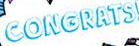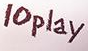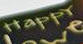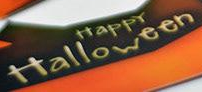Identify the words shown in these images in order, separated by a semicolon. CONGRATS; 10play; HappY; Halloween 